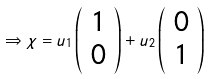<formula> <loc_0><loc_0><loc_500><loc_500>\Rightarrow \chi = u _ { 1 } \left ( \begin{array} { c } 1 \\ 0 \end{array} \right ) + u _ { 2 } \left ( \begin{array} { c } 0 \\ 1 \end{array} \right )</formula> 